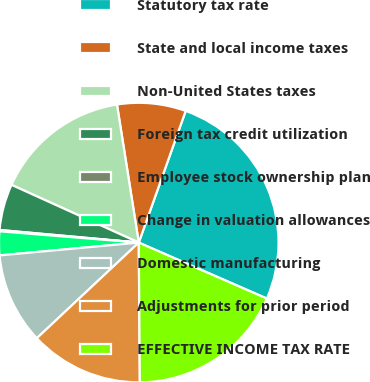Convert chart to OTSL. <chart><loc_0><loc_0><loc_500><loc_500><pie_chart><fcel>Statutory tax rate<fcel>State and local income taxes<fcel>Non-United States taxes<fcel>Foreign tax credit utilization<fcel>Employee stock ownership plan<fcel>Change in valuation allowances<fcel>Domestic manufacturing<fcel>Adjustments for prior period<fcel>EFFECTIVE INCOME TAX RATE<nl><fcel>26.11%<fcel>7.94%<fcel>15.73%<fcel>5.34%<fcel>0.15%<fcel>2.75%<fcel>10.53%<fcel>13.13%<fcel>18.32%<nl></chart> 